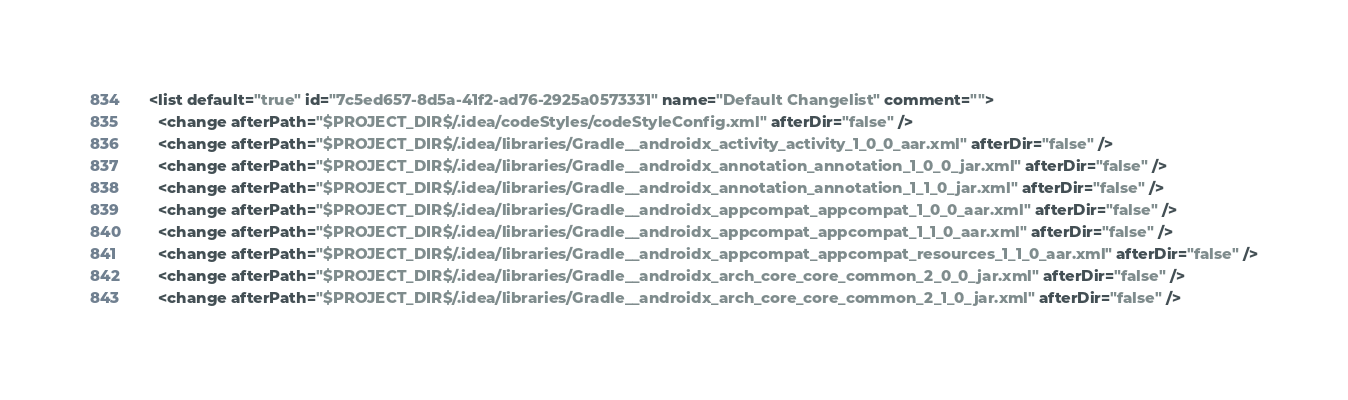Convert code to text. <code><loc_0><loc_0><loc_500><loc_500><_XML_>    <list default="true" id="7c5ed657-8d5a-41f2-ad76-2925a0573331" name="Default Changelist" comment="">
      <change afterPath="$PROJECT_DIR$/.idea/codeStyles/codeStyleConfig.xml" afterDir="false" />
      <change afterPath="$PROJECT_DIR$/.idea/libraries/Gradle__androidx_activity_activity_1_0_0_aar.xml" afterDir="false" />
      <change afterPath="$PROJECT_DIR$/.idea/libraries/Gradle__androidx_annotation_annotation_1_0_0_jar.xml" afterDir="false" />
      <change afterPath="$PROJECT_DIR$/.idea/libraries/Gradle__androidx_annotation_annotation_1_1_0_jar.xml" afterDir="false" />
      <change afterPath="$PROJECT_DIR$/.idea/libraries/Gradle__androidx_appcompat_appcompat_1_0_0_aar.xml" afterDir="false" />
      <change afterPath="$PROJECT_DIR$/.idea/libraries/Gradle__androidx_appcompat_appcompat_1_1_0_aar.xml" afterDir="false" />
      <change afterPath="$PROJECT_DIR$/.idea/libraries/Gradle__androidx_appcompat_appcompat_resources_1_1_0_aar.xml" afterDir="false" />
      <change afterPath="$PROJECT_DIR$/.idea/libraries/Gradle__androidx_arch_core_core_common_2_0_0_jar.xml" afterDir="false" />
      <change afterPath="$PROJECT_DIR$/.idea/libraries/Gradle__androidx_arch_core_core_common_2_1_0_jar.xml" afterDir="false" /></code> 